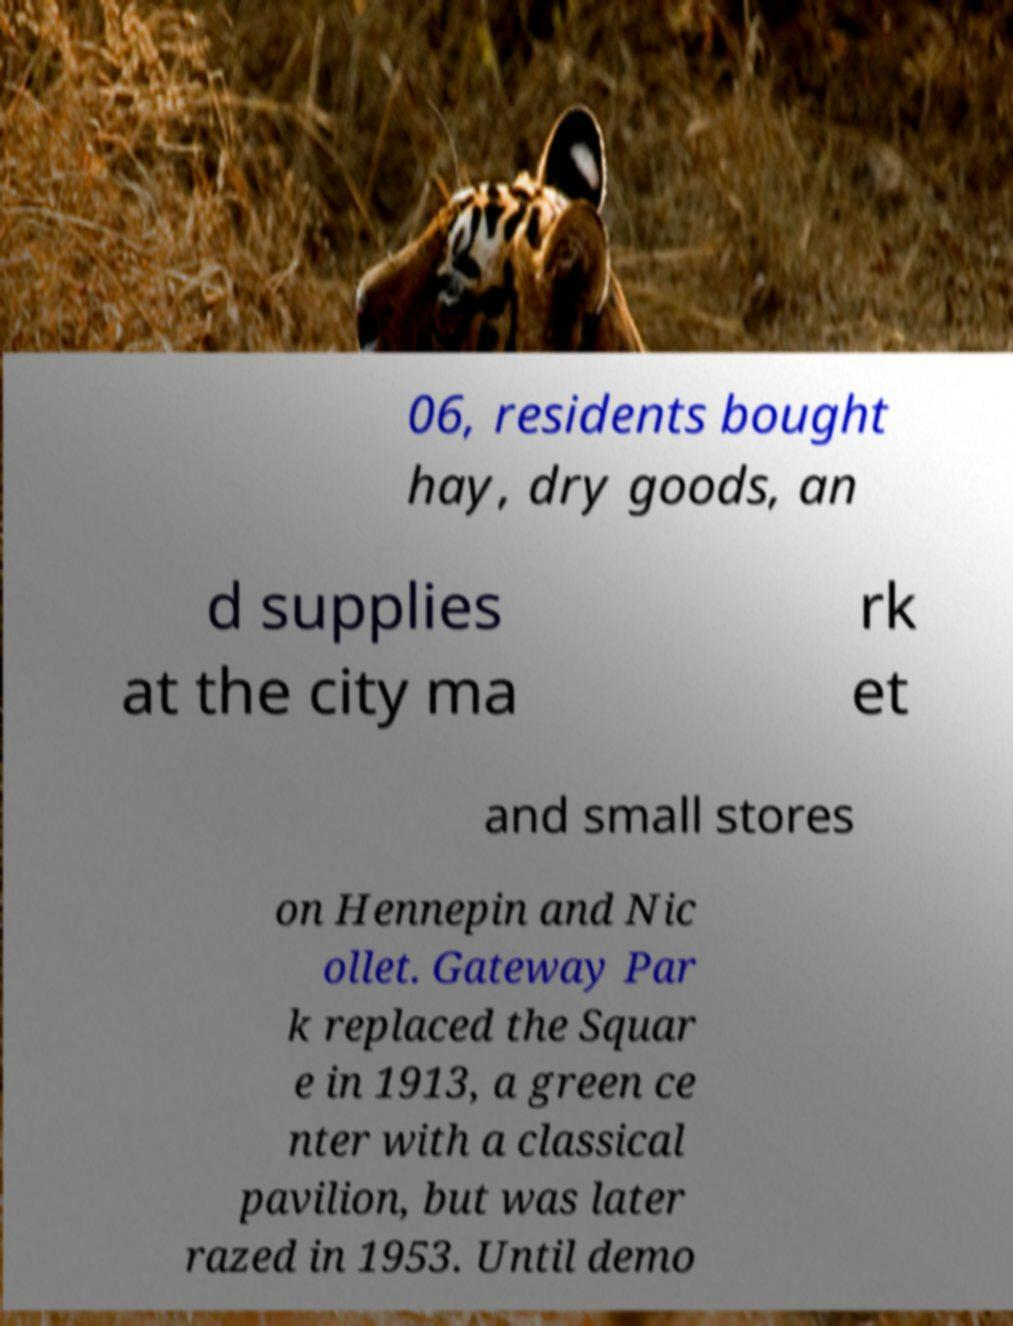For documentation purposes, I need the text within this image transcribed. Could you provide that? 06, residents bought hay, dry goods, an d supplies at the city ma rk et and small stores on Hennepin and Nic ollet. Gateway Par k replaced the Squar e in 1913, a green ce nter with a classical pavilion, but was later razed in 1953. Until demo 